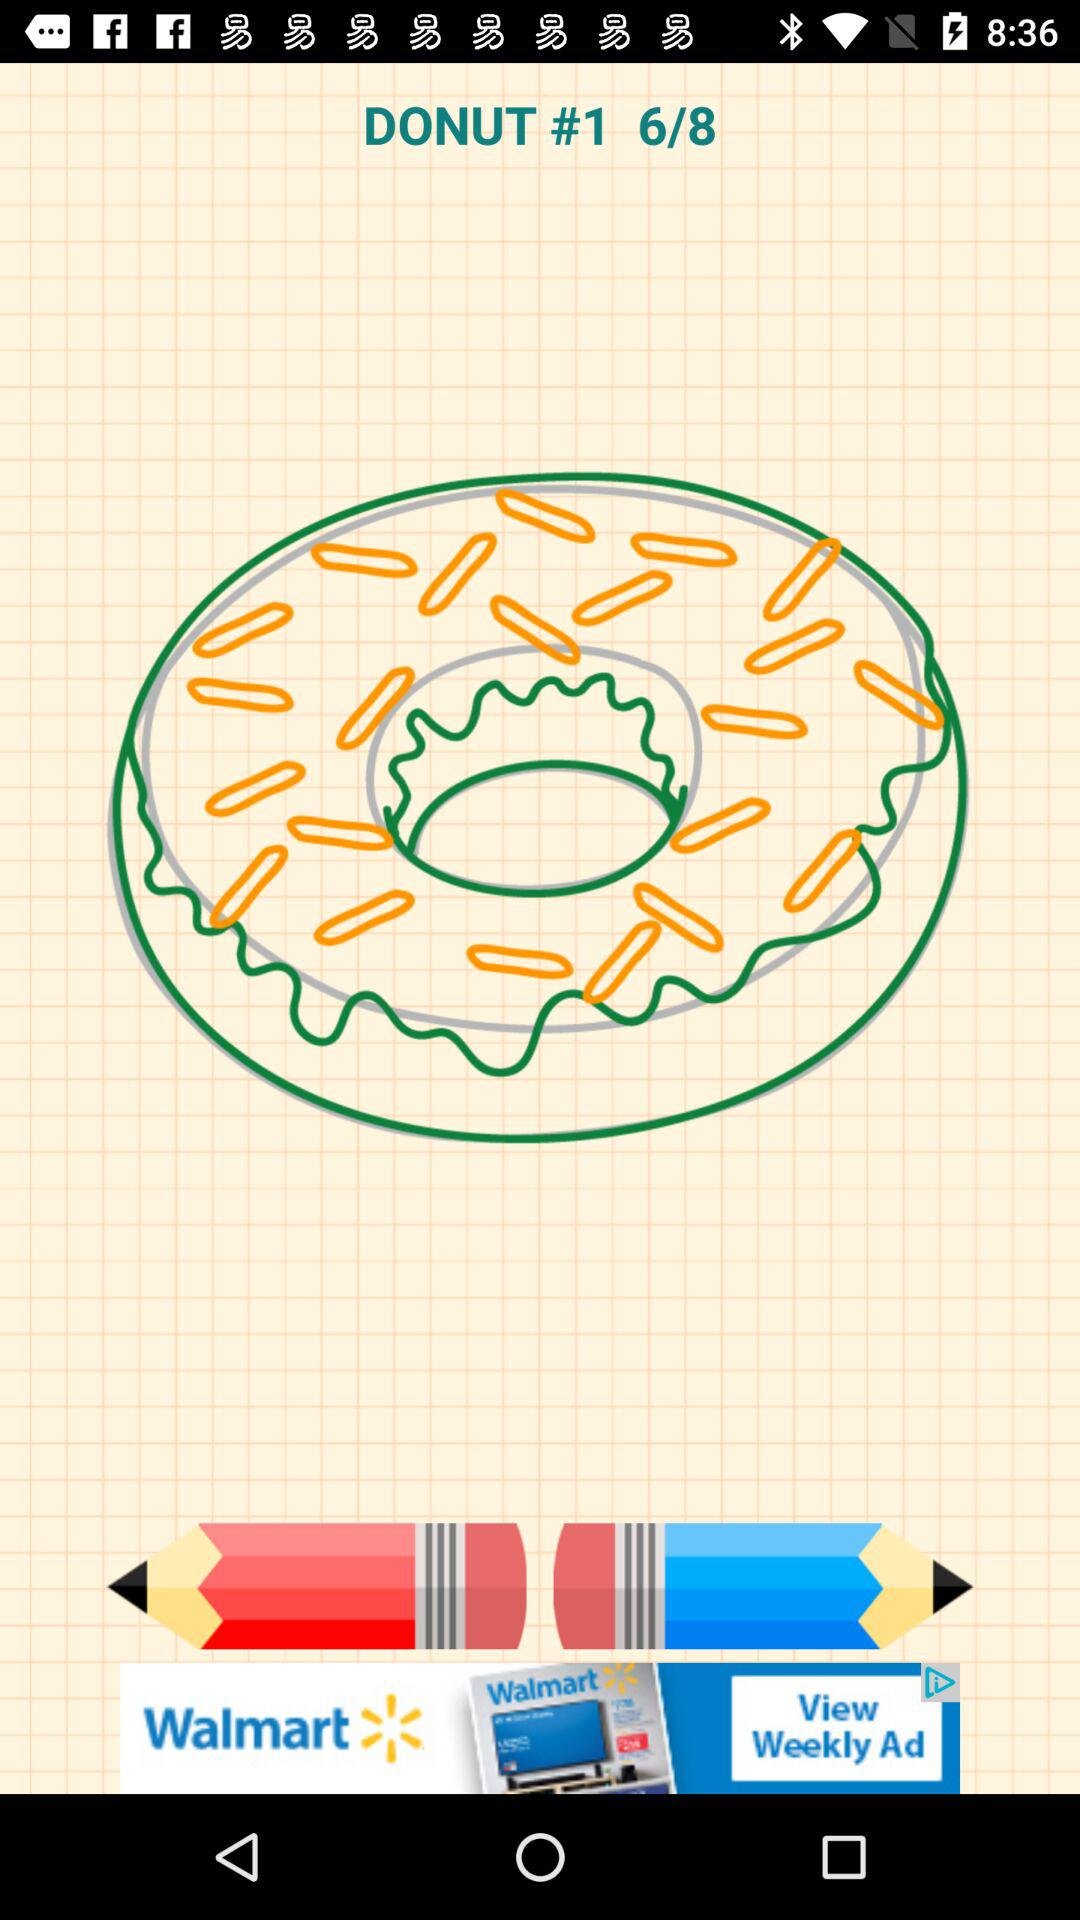How many marks did they get?
When the provided information is insufficient, respond with <no answer>. <no answer> 